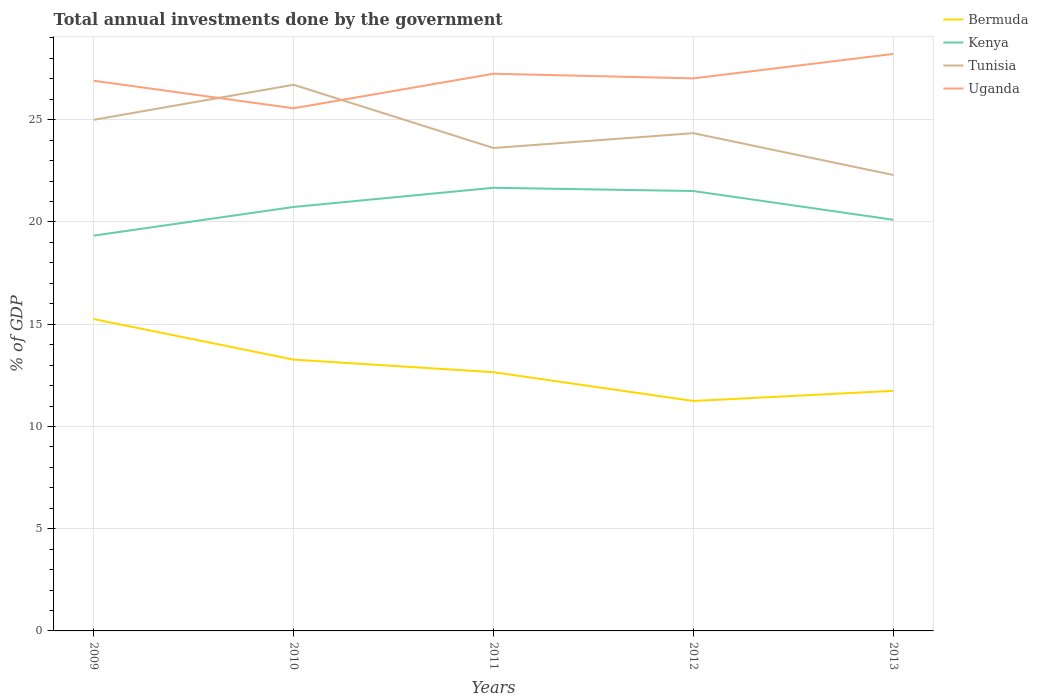Does the line corresponding to Kenya intersect with the line corresponding to Bermuda?
Give a very brief answer. No. Across all years, what is the maximum total annual investments done by the government in Kenya?
Offer a terse response. 19.33. In which year was the total annual investments done by the government in Kenya maximum?
Provide a succinct answer. 2009. What is the total total annual investments done by the government in Tunisia in the graph?
Make the answer very short. 2.7. What is the difference between the highest and the second highest total annual investments done by the government in Uganda?
Your answer should be compact. 2.66. What is the difference between the highest and the lowest total annual investments done by the government in Kenya?
Your response must be concise. 3. Is the total annual investments done by the government in Tunisia strictly greater than the total annual investments done by the government in Bermuda over the years?
Offer a terse response. No. What is the difference between two consecutive major ticks on the Y-axis?
Keep it short and to the point. 5. Are the values on the major ticks of Y-axis written in scientific E-notation?
Keep it short and to the point. No. Does the graph contain any zero values?
Give a very brief answer. No. Does the graph contain grids?
Provide a short and direct response. Yes. Where does the legend appear in the graph?
Provide a succinct answer. Top right. How many legend labels are there?
Ensure brevity in your answer.  4. What is the title of the graph?
Your response must be concise. Total annual investments done by the government. What is the label or title of the X-axis?
Your answer should be compact. Years. What is the label or title of the Y-axis?
Provide a short and direct response. % of GDP. What is the % of GDP of Bermuda in 2009?
Offer a very short reply. 15.25. What is the % of GDP in Kenya in 2009?
Ensure brevity in your answer.  19.33. What is the % of GDP of Tunisia in 2009?
Keep it short and to the point. 25. What is the % of GDP in Uganda in 2009?
Give a very brief answer. 26.91. What is the % of GDP of Bermuda in 2010?
Offer a terse response. 13.27. What is the % of GDP in Kenya in 2010?
Your response must be concise. 20.73. What is the % of GDP of Tunisia in 2010?
Offer a terse response. 26.71. What is the % of GDP in Uganda in 2010?
Provide a succinct answer. 25.56. What is the % of GDP in Bermuda in 2011?
Give a very brief answer. 12.65. What is the % of GDP of Kenya in 2011?
Your answer should be very brief. 21.67. What is the % of GDP in Tunisia in 2011?
Give a very brief answer. 23.62. What is the % of GDP in Uganda in 2011?
Your response must be concise. 27.25. What is the % of GDP in Bermuda in 2012?
Provide a short and direct response. 11.25. What is the % of GDP in Kenya in 2012?
Offer a terse response. 21.51. What is the % of GDP in Tunisia in 2012?
Ensure brevity in your answer.  24.34. What is the % of GDP of Uganda in 2012?
Provide a short and direct response. 27.02. What is the % of GDP in Bermuda in 2013?
Give a very brief answer. 11.74. What is the % of GDP of Kenya in 2013?
Keep it short and to the point. 20.11. What is the % of GDP in Tunisia in 2013?
Offer a terse response. 22.3. What is the % of GDP in Uganda in 2013?
Offer a terse response. 28.22. Across all years, what is the maximum % of GDP of Bermuda?
Offer a very short reply. 15.25. Across all years, what is the maximum % of GDP in Kenya?
Offer a very short reply. 21.67. Across all years, what is the maximum % of GDP in Tunisia?
Make the answer very short. 26.71. Across all years, what is the maximum % of GDP in Uganda?
Make the answer very short. 28.22. Across all years, what is the minimum % of GDP of Bermuda?
Offer a very short reply. 11.25. Across all years, what is the minimum % of GDP in Kenya?
Your answer should be compact. 19.33. Across all years, what is the minimum % of GDP in Tunisia?
Your answer should be compact. 22.3. Across all years, what is the minimum % of GDP in Uganda?
Your answer should be very brief. 25.56. What is the total % of GDP of Bermuda in the graph?
Provide a short and direct response. 64.16. What is the total % of GDP of Kenya in the graph?
Offer a very short reply. 103.36. What is the total % of GDP in Tunisia in the graph?
Your answer should be compact. 121.97. What is the total % of GDP of Uganda in the graph?
Offer a very short reply. 134.97. What is the difference between the % of GDP in Bermuda in 2009 and that in 2010?
Give a very brief answer. 1.98. What is the difference between the % of GDP in Kenya in 2009 and that in 2010?
Make the answer very short. -1.4. What is the difference between the % of GDP in Tunisia in 2009 and that in 2010?
Your response must be concise. -1.72. What is the difference between the % of GDP in Uganda in 2009 and that in 2010?
Offer a terse response. 1.35. What is the difference between the % of GDP of Bermuda in 2009 and that in 2011?
Offer a very short reply. 2.6. What is the difference between the % of GDP of Kenya in 2009 and that in 2011?
Offer a very short reply. -2.34. What is the difference between the % of GDP of Tunisia in 2009 and that in 2011?
Provide a short and direct response. 1.38. What is the difference between the % of GDP in Uganda in 2009 and that in 2011?
Offer a terse response. -0.34. What is the difference between the % of GDP in Bermuda in 2009 and that in 2012?
Give a very brief answer. 4.01. What is the difference between the % of GDP in Kenya in 2009 and that in 2012?
Give a very brief answer. -2.18. What is the difference between the % of GDP of Tunisia in 2009 and that in 2012?
Provide a short and direct response. 0.65. What is the difference between the % of GDP in Uganda in 2009 and that in 2012?
Your answer should be very brief. -0.12. What is the difference between the % of GDP in Bermuda in 2009 and that in 2013?
Your answer should be very brief. 3.51. What is the difference between the % of GDP in Kenya in 2009 and that in 2013?
Your answer should be very brief. -0.78. What is the difference between the % of GDP of Tunisia in 2009 and that in 2013?
Your response must be concise. 2.7. What is the difference between the % of GDP in Uganda in 2009 and that in 2013?
Provide a succinct answer. -1.31. What is the difference between the % of GDP of Bermuda in 2010 and that in 2011?
Offer a very short reply. 0.62. What is the difference between the % of GDP of Kenya in 2010 and that in 2011?
Make the answer very short. -0.94. What is the difference between the % of GDP in Tunisia in 2010 and that in 2011?
Make the answer very short. 3.09. What is the difference between the % of GDP of Uganda in 2010 and that in 2011?
Your answer should be very brief. -1.69. What is the difference between the % of GDP in Bermuda in 2010 and that in 2012?
Ensure brevity in your answer.  2.02. What is the difference between the % of GDP in Kenya in 2010 and that in 2012?
Your answer should be compact. -0.78. What is the difference between the % of GDP of Tunisia in 2010 and that in 2012?
Your answer should be very brief. 2.37. What is the difference between the % of GDP of Uganda in 2010 and that in 2012?
Your response must be concise. -1.46. What is the difference between the % of GDP of Bermuda in 2010 and that in 2013?
Keep it short and to the point. 1.53. What is the difference between the % of GDP in Kenya in 2010 and that in 2013?
Your answer should be compact. 0.63. What is the difference between the % of GDP of Tunisia in 2010 and that in 2013?
Make the answer very short. 4.41. What is the difference between the % of GDP of Uganda in 2010 and that in 2013?
Offer a terse response. -2.66. What is the difference between the % of GDP of Bermuda in 2011 and that in 2012?
Your answer should be compact. 1.41. What is the difference between the % of GDP of Kenya in 2011 and that in 2012?
Offer a terse response. 0.16. What is the difference between the % of GDP in Tunisia in 2011 and that in 2012?
Offer a terse response. -0.72. What is the difference between the % of GDP of Uganda in 2011 and that in 2012?
Keep it short and to the point. 0.23. What is the difference between the % of GDP of Bermuda in 2011 and that in 2013?
Offer a very short reply. 0.91. What is the difference between the % of GDP in Kenya in 2011 and that in 2013?
Make the answer very short. 1.56. What is the difference between the % of GDP in Tunisia in 2011 and that in 2013?
Offer a very short reply. 1.32. What is the difference between the % of GDP in Uganda in 2011 and that in 2013?
Your response must be concise. -0.97. What is the difference between the % of GDP in Bermuda in 2012 and that in 2013?
Give a very brief answer. -0.5. What is the difference between the % of GDP in Kenya in 2012 and that in 2013?
Offer a very short reply. 1.41. What is the difference between the % of GDP in Tunisia in 2012 and that in 2013?
Provide a short and direct response. 2.04. What is the difference between the % of GDP of Uganda in 2012 and that in 2013?
Provide a succinct answer. -1.2. What is the difference between the % of GDP in Bermuda in 2009 and the % of GDP in Kenya in 2010?
Offer a terse response. -5.48. What is the difference between the % of GDP in Bermuda in 2009 and the % of GDP in Tunisia in 2010?
Provide a succinct answer. -11.46. What is the difference between the % of GDP in Bermuda in 2009 and the % of GDP in Uganda in 2010?
Offer a terse response. -10.31. What is the difference between the % of GDP in Kenya in 2009 and the % of GDP in Tunisia in 2010?
Make the answer very short. -7.38. What is the difference between the % of GDP in Kenya in 2009 and the % of GDP in Uganda in 2010?
Keep it short and to the point. -6.23. What is the difference between the % of GDP of Tunisia in 2009 and the % of GDP of Uganda in 2010?
Offer a very short reply. -0.57. What is the difference between the % of GDP of Bermuda in 2009 and the % of GDP of Kenya in 2011?
Provide a succinct answer. -6.42. What is the difference between the % of GDP of Bermuda in 2009 and the % of GDP of Tunisia in 2011?
Your response must be concise. -8.37. What is the difference between the % of GDP in Bermuda in 2009 and the % of GDP in Uganda in 2011?
Offer a terse response. -12. What is the difference between the % of GDP of Kenya in 2009 and the % of GDP of Tunisia in 2011?
Provide a succinct answer. -4.29. What is the difference between the % of GDP of Kenya in 2009 and the % of GDP of Uganda in 2011?
Your answer should be very brief. -7.92. What is the difference between the % of GDP of Tunisia in 2009 and the % of GDP of Uganda in 2011?
Ensure brevity in your answer.  -2.26. What is the difference between the % of GDP of Bermuda in 2009 and the % of GDP of Kenya in 2012?
Your answer should be very brief. -6.26. What is the difference between the % of GDP of Bermuda in 2009 and the % of GDP of Tunisia in 2012?
Ensure brevity in your answer.  -9.09. What is the difference between the % of GDP in Bermuda in 2009 and the % of GDP in Uganda in 2012?
Ensure brevity in your answer.  -11.77. What is the difference between the % of GDP in Kenya in 2009 and the % of GDP in Tunisia in 2012?
Offer a terse response. -5.01. What is the difference between the % of GDP of Kenya in 2009 and the % of GDP of Uganda in 2012?
Offer a very short reply. -7.69. What is the difference between the % of GDP of Tunisia in 2009 and the % of GDP of Uganda in 2012?
Give a very brief answer. -2.03. What is the difference between the % of GDP of Bermuda in 2009 and the % of GDP of Kenya in 2013?
Make the answer very short. -4.86. What is the difference between the % of GDP of Bermuda in 2009 and the % of GDP of Tunisia in 2013?
Your response must be concise. -7.05. What is the difference between the % of GDP in Bermuda in 2009 and the % of GDP in Uganda in 2013?
Offer a very short reply. -12.97. What is the difference between the % of GDP of Kenya in 2009 and the % of GDP of Tunisia in 2013?
Keep it short and to the point. -2.97. What is the difference between the % of GDP in Kenya in 2009 and the % of GDP in Uganda in 2013?
Your answer should be very brief. -8.89. What is the difference between the % of GDP in Tunisia in 2009 and the % of GDP in Uganda in 2013?
Ensure brevity in your answer.  -3.22. What is the difference between the % of GDP of Bermuda in 2010 and the % of GDP of Kenya in 2011?
Keep it short and to the point. -8.4. What is the difference between the % of GDP in Bermuda in 2010 and the % of GDP in Tunisia in 2011?
Your answer should be very brief. -10.35. What is the difference between the % of GDP in Bermuda in 2010 and the % of GDP in Uganda in 2011?
Offer a terse response. -13.98. What is the difference between the % of GDP of Kenya in 2010 and the % of GDP of Tunisia in 2011?
Provide a short and direct response. -2.88. What is the difference between the % of GDP of Kenya in 2010 and the % of GDP of Uganda in 2011?
Give a very brief answer. -6.52. What is the difference between the % of GDP in Tunisia in 2010 and the % of GDP in Uganda in 2011?
Your answer should be compact. -0.54. What is the difference between the % of GDP of Bermuda in 2010 and the % of GDP of Kenya in 2012?
Keep it short and to the point. -8.24. What is the difference between the % of GDP in Bermuda in 2010 and the % of GDP in Tunisia in 2012?
Offer a very short reply. -11.07. What is the difference between the % of GDP of Bermuda in 2010 and the % of GDP of Uganda in 2012?
Make the answer very short. -13.75. What is the difference between the % of GDP of Kenya in 2010 and the % of GDP of Tunisia in 2012?
Keep it short and to the point. -3.61. What is the difference between the % of GDP in Kenya in 2010 and the % of GDP in Uganda in 2012?
Your response must be concise. -6.29. What is the difference between the % of GDP of Tunisia in 2010 and the % of GDP of Uganda in 2012?
Make the answer very short. -0.31. What is the difference between the % of GDP of Bermuda in 2010 and the % of GDP of Kenya in 2013?
Offer a very short reply. -6.84. What is the difference between the % of GDP of Bermuda in 2010 and the % of GDP of Tunisia in 2013?
Ensure brevity in your answer.  -9.03. What is the difference between the % of GDP in Bermuda in 2010 and the % of GDP in Uganda in 2013?
Your answer should be compact. -14.95. What is the difference between the % of GDP in Kenya in 2010 and the % of GDP in Tunisia in 2013?
Your answer should be compact. -1.56. What is the difference between the % of GDP of Kenya in 2010 and the % of GDP of Uganda in 2013?
Keep it short and to the point. -7.48. What is the difference between the % of GDP of Tunisia in 2010 and the % of GDP of Uganda in 2013?
Your answer should be compact. -1.51. What is the difference between the % of GDP of Bermuda in 2011 and the % of GDP of Kenya in 2012?
Offer a very short reply. -8.86. What is the difference between the % of GDP in Bermuda in 2011 and the % of GDP in Tunisia in 2012?
Keep it short and to the point. -11.69. What is the difference between the % of GDP of Bermuda in 2011 and the % of GDP of Uganda in 2012?
Your answer should be compact. -14.37. What is the difference between the % of GDP in Kenya in 2011 and the % of GDP in Tunisia in 2012?
Your answer should be compact. -2.67. What is the difference between the % of GDP in Kenya in 2011 and the % of GDP in Uganda in 2012?
Offer a very short reply. -5.35. What is the difference between the % of GDP in Tunisia in 2011 and the % of GDP in Uganda in 2012?
Give a very brief answer. -3.41. What is the difference between the % of GDP of Bermuda in 2011 and the % of GDP of Kenya in 2013?
Ensure brevity in your answer.  -7.46. What is the difference between the % of GDP in Bermuda in 2011 and the % of GDP in Tunisia in 2013?
Offer a terse response. -9.65. What is the difference between the % of GDP of Bermuda in 2011 and the % of GDP of Uganda in 2013?
Provide a succinct answer. -15.57. What is the difference between the % of GDP of Kenya in 2011 and the % of GDP of Tunisia in 2013?
Your answer should be compact. -0.63. What is the difference between the % of GDP in Kenya in 2011 and the % of GDP in Uganda in 2013?
Provide a succinct answer. -6.55. What is the difference between the % of GDP of Tunisia in 2011 and the % of GDP of Uganda in 2013?
Ensure brevity in your answer.  -4.6. What is the difference between the % of GDP in Bermuda in 2012 and the % of GDP in Kenya in 2013?
Ensure brevity in your answer.  -8.86. What is the difference between the % of GDP in Bermuda in 2012 and the % of GDP in Tunisia in 2013?
Offer a terse response. -11.05. What is the difference between the % of GDP of Bermuda in 2012 and the % of GDP of Uganda in 2013?
Make the answer very short. -16.97. What is the difference between the % of GDP in Kenya in 2012 and the % of GDP in Tunisia in 2013?
Your answer should be very brief. -0.78. What is the difference between the % of GDP in Kenya in 2012 and the % of GDP in Uganda in 2013?
Your answer should be very brief. -6.71. What is the difference between the % of GDP in Tunisia in 2012 and the % of GDP in Uganda in 2013?
Offer a terse response. -3.88. What is the average % of GDP of Bermuda per year?
Provide a short and direct response. 12.83. What is the average % of GDP in Kenya per year?
Your answer should be compact. 20.67. What is the average % of GDP in Tunisia per year?
Offer a very short reply. 24.39. What is the average % of GDP in Uganda per year?
Give a very brief answer. 26.99. In the year 2009, what is the difference between the % of GDP in Bermuda and % of GDP in Kenya?
Offer a very short reply. -4.08. In the year 2009, what is the difference between the % of GDP in Bermuda and % of GDP in Tunisia?
Offer a very short reply. -9.74. In the year 2009, what is the difference between the % of GDP of Bermuda and % of GDP of Uganda?
Keep it short and to the point. -11.66. In the year 2009, what is the difference between the % of GDP of Kenya and % of GDP of Tunisia?
Make the answer very short. -5.66. In the year 2009, what is the difference between the % of GDP in Kenya and % of GDP in Uganda?
Your answer should be very brief. -7.58. In the year 2009, what is the difference between the % of GDP in Tunisia and % of GDP in Uganda?
Offer a very short reply. -1.91. In the year 2010, what is the difference between the % of GDP of Bermuda and % of GDP of Kenya?
Give a very brief answer. -7.47. In the year 2010, what is the difference between the % of GDP in Bermuda and % of GDP in Tunisia?
Provide a short and direct response. -13.44. In the year 2010, what is the difference between the % of GDP in Bermuda and % of GDP in Uganda?
Your response must be concise. -12.29. In the year 2010, what is the difference between the % of GDP of Kenya and % of GDP of Tunisia?
Give a very brief answer. -5.98. In the year 2010, what is the difference between the % of GDP in Kenya and % of GDP in Uganda?
Your answer should be compact. -4.83. In the year 2010, what is the difference between the % of GDP of Tunisia and % of GDP of Uganda?
Keep it short and to the point. 1.15. In the year 2011, what is the difference between the % of GDP in Bermuda and % of GDP in Kenya?
Keep it short and to the point. -9.02. In the year 2011, what is the difference between the % of GDP of Bermuda and % of GDP of Tunisia?
Make the answer very short. -10.97. In the year 2011, what is the difference between the % of GDP in Bermuda and % of GDP in Uganda?
Your response must be concise. -14.6. In the year 2011, what is the difference between the % of GDP of Kenya and % of GDP of Tunisia?
Your answer should be compact. -1.95. In the year 2011, what is the difference between the % of GDP of Kenya and % of GDP of Uganda?
Keep it short and to the point. -5.58. In the year 2011, what is the difference between the % of GDP in Tunisia and % of GDP in Uganda?
Give a very brief answer. -3.63. In the year 2012, what is the difference between the % of GDP of Bermuda and % of GDP of Kenya?
Offer a terse response. -10.27. In the year 2012, what is the difference between the % of GDP in Bermuda and % of GDP in Tunisia?
Your answer should be compact. -13.1. In the year 2012, what is the difference between the % of GDP of Bermuda and % of GDP of Uganda?
Ensure brevity in your answer.  -15.78. In the year 2012, what is the difference between the % of GDP in Kenya and % of GDP in Tunisia?
Keep it short and to the point. -2.83. In the year 2012, what is the difference between the % of GDP in Kenya and % of GDP in Uganda?
Make the answer very short. -5.51. In the year 2012, what is the difference between the % of GDP of Tunisia and % of GDP of Uganda?
Provide a short and direct response. -2.68. In the year 2013, what is the difference between the % of GDP in Bermuda and % of GDP in Kenya?
Offer a terse response. -8.37. In the year 2013, what is the difference between the % of GDP of Bermuda and % of GDP of Tunisia?
Offer a very short reply. -10.56. In the year 2013, what is the difference between the % of GDP in Bermuda and % of GDP in Uganda?
Your answer should be very brief. -16.48. In the year 2013, what is the difference between the % of GDP of Kenya and % of GDP of Tunisia?
Keep it short and to the point. -2.19. In the year 2013, what is the difference between the % of GDP of Kenya and % of GDP of Uganda?
Give a very brief answer. -8.11. In the year 2013, what is the difference between the % of GDP of Tunisia and % of GDP of Uganda?
Provide a succinct answer. -5.92. What is the ratio of the % of GDP in Bermuda in 2009 to that in 2010?
Provide a succinct answer. 1.15. What is the ratio of the % of GDP of Kenya in 2009 to that in 2010?
Provide a short and direct response. 0.93. What is the ratio of the % of GDP in Tunisia in 2009 to that in 2010?
Provide a short and direct response. 0.94. What is the ratio of the % of GDP in Uganda in 2009 to that in 2010?
Offer a very short reply. 1.05. What is the ratio of the % of GDP of Bermuda in 2009 to that in 2011?
Keep it short and to the point. 1.21. What is the ratio of the % of GDP of Kenya in 2009 to that in 2011?
Give a very brief answer. 0.89. What is the ratio of the % of GDP in Tunisia in 2009 to that in 2011?
Your response must be concise. 1.06. What is the ratio of the % of GDP of Uganda in 2009 to that in 2011?
Ensure brevity in your answer.  0.99. What is the ratio of the % of GDP in Bermuda in 2009 to that in 2012?
Ensure brevity in your answer.  1.36. What is the ratio of the % of GDP of Kenya in 2009 to that in 2012?
Your answer should be compact. 0.9. What is the ratio of the % of GDP of Tunisia in 2009 to that in 2012?
Offer a terse response. 1.03. What is the ratio of the % of GDP of Bermuda in 2009 to that in 2013?
Make the answer very short. 1.3. What is the ratio of the % of GDP in Kenya in 2009 to that in 2013?
Ensure brevity in your answer.  0.96. What is the ratio of the % of GDP of Tunisia in 2009 to that in 2013?
Give a very brief answer. 1.12. What is the ratio of the % of GDP of Uganda in 2009 to that in 2013?
Your response must be concise. 0.95. What is the ratio of the % of GDP in Bermuda in 2010 to that in 2011?
Make the answer very short. 1.05. What is the ratio of the % of GDP in Kenya in 2010 to that in 2011?
Provide a succinct answer. 0.96. What is the ratio of the % of GDP of Tunisia in 2010 to that in 2011?
Give a very brief answer. 1.13. What is the ratio of the % of GDP in Uganda in 2010 to that in 2011?
Offer a terse response. 0.94. What is the ratio of the % of GDP of Bermuda in 2010 to that in 2012?
Provide a succinct answer. 1.18. What is the ratio of the % of GDP of Kenya in 2010 to that in 2012?
Give a very brief answer. 0.96. What is the ratio of the % of GDP in Tunisia in 2010 to that in 2012?
Your answer should be compact. 1.1. What is the ratio of the % of GDP in Uganda in 2010 to that in 2012?
Offer a very short reply. 0.95. What is the ratio of the % of GDP in Bermuda in 2010 to that in 2013?
Your response must be concise. 1.13. What is the ratio of the % of GDP of Kenya in 2010 to that in 2013?
Make the answer very short. 1.03. What is the ratio of the % of GDP of Tunisia in 2010 to that in 2013?
Provide a short and direct response. 1.2. What is the ratio of the % of GDP in Uganda in 2010 to that in 2013?
Provide a short and direct response. 0.91. What is the ratio of the % of GDP in Bermuda in 2011 to that in 2012?
Keep it short and to the point. 1.13. What is the ratio of the % of GDP in Kenya in 2011 to that in 2012?
Your response must be concise. 1.01. What is the ratio of the % of GDP of Tunisia in 2011 to that in 2012?
Keep it short and to the point. 0.97. What is the ratio of the % of GDP in Uganda in 2011 to that in 2012?
Keep it short and to the point. 1.01. What is the ratio of the % of GDP of Bermuda in 2011 to that in 2013?
Your answer should be compact. 1.08. What is the ratio of the % of GDP of Kenya in 2011 to that in 2013?
Provide a succinct answer. 1.08. What is the ratio of the % of GDP in Tunisia in 2011 to that in 2013?
Provide a short and direct response. 1.06. What is the ratio of the % of GDP in Uganda in 2011 to that in 2013?
Give a very brief answer. 0.97. What is the ratio of the % of GDP of Bermuda in 2012 to that in 2013?
Offer a very short reply. 0.96. What is the ratio of the % of GDP in Kenya in 2012 to that in 2013?
Your answer should be very brief. 1.07. What is the ratio of the % of GDP of Tunisia in 2012 to that in 2013?
Offer a very short reply. 1.09. What is the ratio of the % of GDP in Uganda in 2012 to that in 2013?
Provide a short and direct response. 0.96. What is the difference between the highest and the second highest % of GDP of Bermuda?
Give a very brief answer. 1.98. What is the difference between the highest and the second highest % of GDP in Kenya?
Your response must be concise. 0.16. What is the difference between the highest and the second highest % of GDP of Tunisia?
Make the answer very short. 1.72. What is the difference between the highest and the second highest % of GDP in Uganda?
Keep it short and to the point. 0.97. What is the difference between the highest and the lowest % of GDP in Bermuda?
Your response must be concise. 4.01. What is the difference between the highest and the lowest % of GDP of Kenya?
Give a very brief answer. 2.34. What is the difference between the highest and the lowest % of GDP of Tunisia?
Your answer should be compact. 4.41. What is the difference between the highest and the lowest % of GDP in Uganda?
Give a very brief answer. 2.66. 